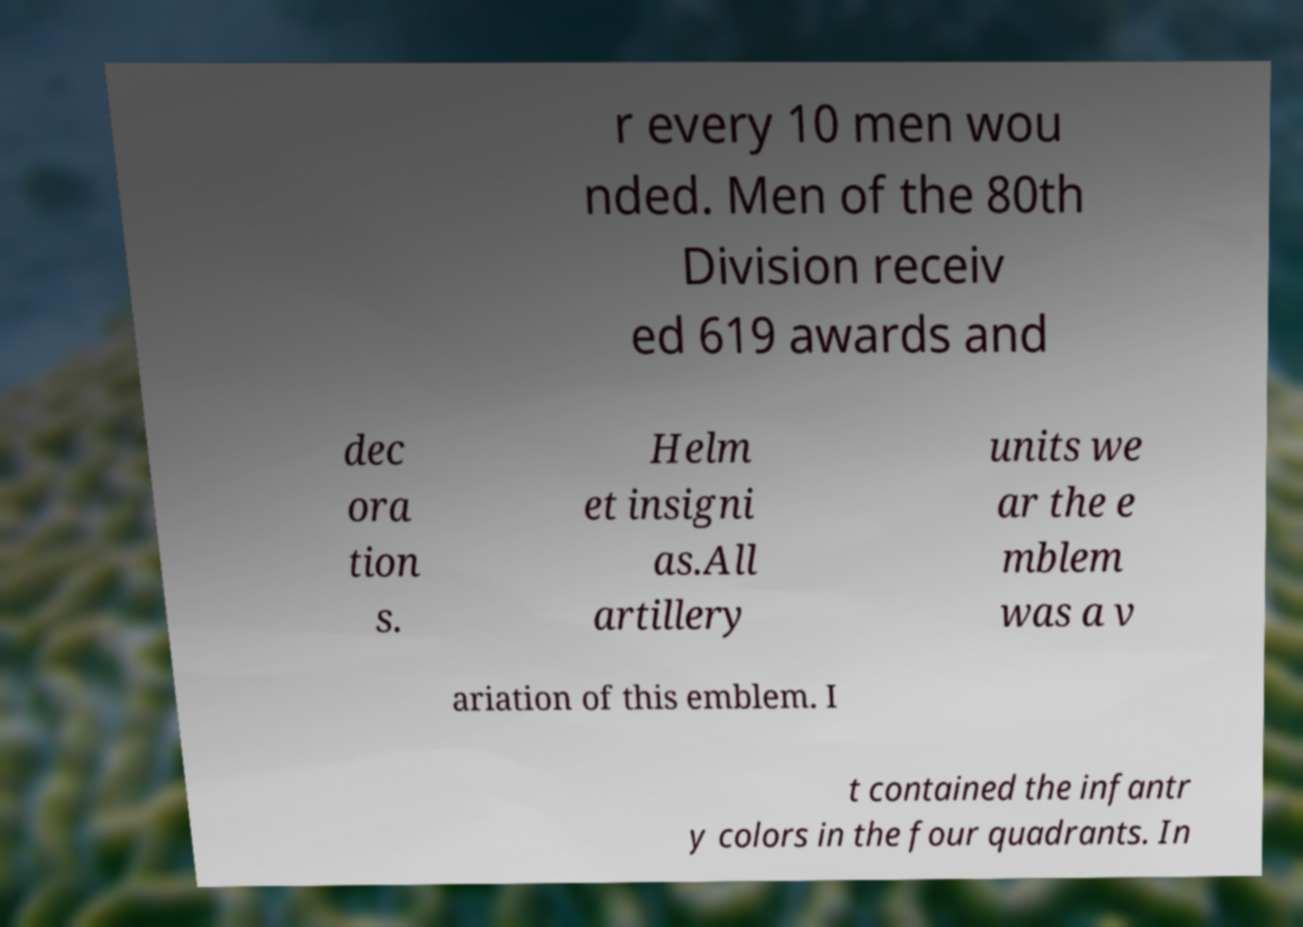There's text embedded in this image that I need extracted. Can you transcribe it verbatim? r every 10 men wou nded. Men of the 80th Division receiv ed 619 awards and dec ora tion s. Helm et insigni as.All artillery units we ar the e mblem was a v ariation of this emblem. I t contained the infantr y colors in the four quadrants. In 